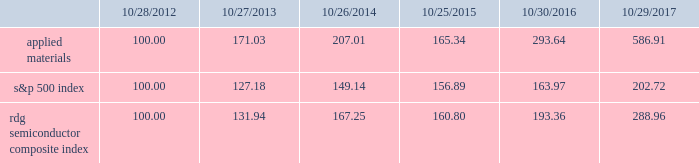Performance graph the performance graph below shows the five-year cumulative total stockholder return on applied common stock during the period from october 28 , 2012 through october 29 , 2017 .
This is compared with the cumulative total return of the standard & poor 2019s 500 stock index and the rdg semiconductor composite index over the same period .
The comparison assumes $ 100 was invested on october 28 , 2012 in applied common stock and in each of the foregoing indices and assumes reinvestment of dividends , if any .
Dollar amounts in the graph are rounded to the nearest whole dollar .
The performance shown in the graph represents past performance and should not be considered an indication of future performance .
Comparison of 5 year cumulative total return* among applied materials , inc. , the s&p 500 index and the rdg semiconductor composite index *assumes $ 100 invested on 10/28/12 in stock or 10/31/12 in index , including reinvestment of dividends .
Indexes calculated on month-end basis .
Copyright a9 2017 standard & poor 2019s , a division of s&p global .
All rights reserved. .
Dividends during each of fiscal 2017 , 2016 and 2015 , applied 2019s board of directors declared four quarterly cash dividends in the amount of $ 0.10 per share .
Applied currently anticipates that cash dividends will continue to be paid on a quarterly basis , although the declaration of any future cash dividend is at the discretion of the board of directors and will depend on applied 2019s financial condition , results of operations , capital requirements , business conditions and other factors , as well as a determination by the board of directors that cash dividends are in the best interests of applied 2019s stockholders .
10/28/12 10/27/13 10/26/14 10/25/15 10/30/16 10/29/17 applied materials , inc .
S&p 500 rdg semiconductor composite .
What is the roi in applied materials if the investment was made in 2012 and sold in 2015? 
Computations: ((165.34 - 100) / 100)
Answer: 0.6534. 